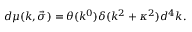<formula> <loc_0><loc_0><loc_500><loc_500>d \mu ( k , \vec { \sigma } ) = \theta ( k ^ { 0 } ) \delta ( k ^ { 2 } + \kappa ^ { 2 } ) d ^ { 4 } k .</formula> 